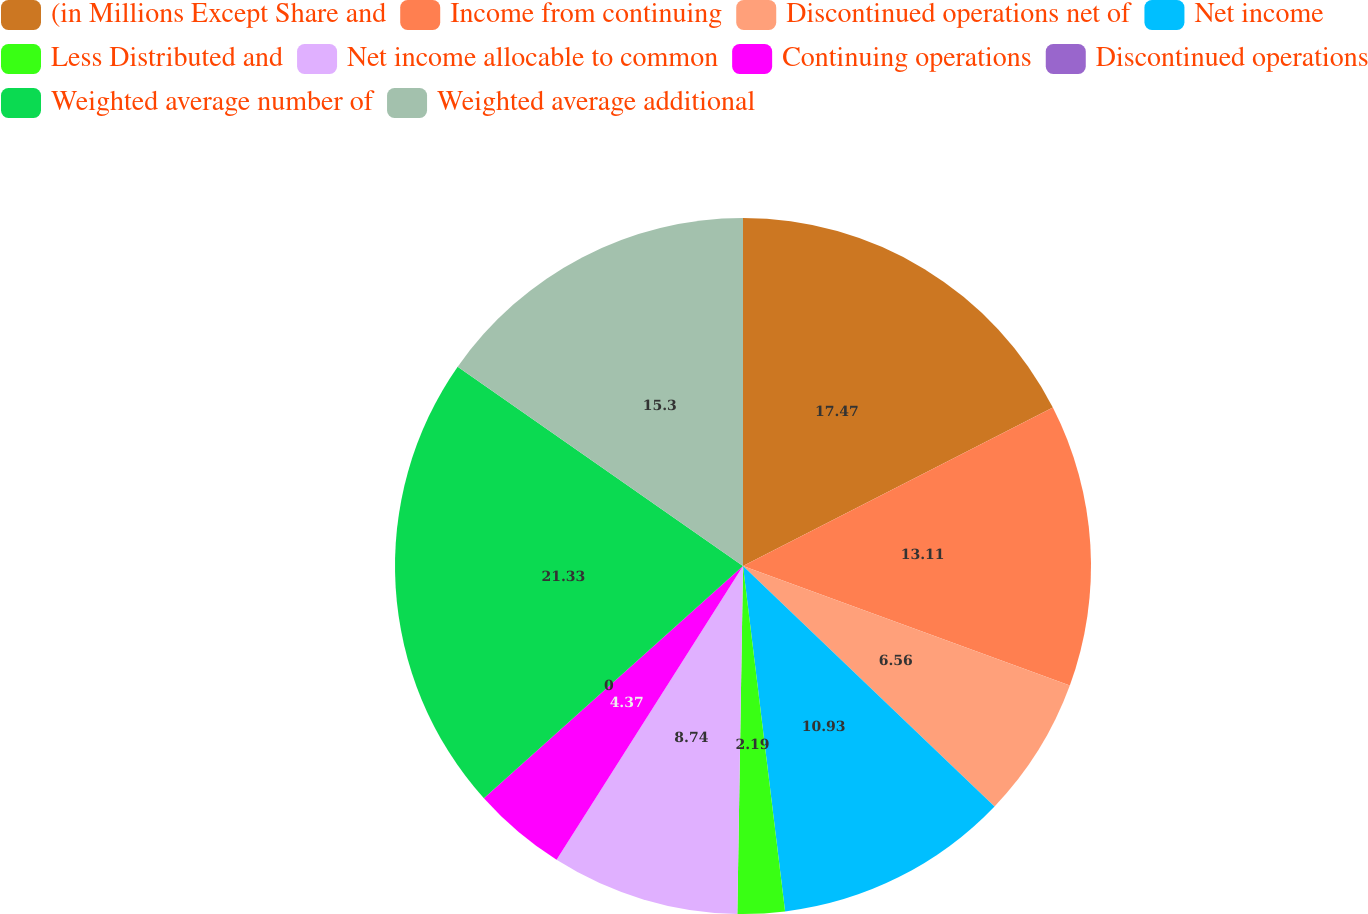Convert chart to OTSL. <chart><loc_0><loc_0><loc_500><loc_500><pie_chart><fcel>(in Millions Except Share and<fcel>Income from continuing<fcel>Discontinued operations net of<fcel>Net income<fcel>Less Distributed and<fcel>Net income allocable to common<fcel>Continuing operations<fcel>Discontinued operations<fcel>Weighted average number of<fcel>Weighted average additional<nl><fcel>17.48%<fcel>13.11%<fcel>6.56%<fcel>10.93%<fcel>2.19%<fcel>8.74%<fcel>4.37%<fcel>0.0%<fcel>21.34%<fcel>15.3%<nl></chart> 